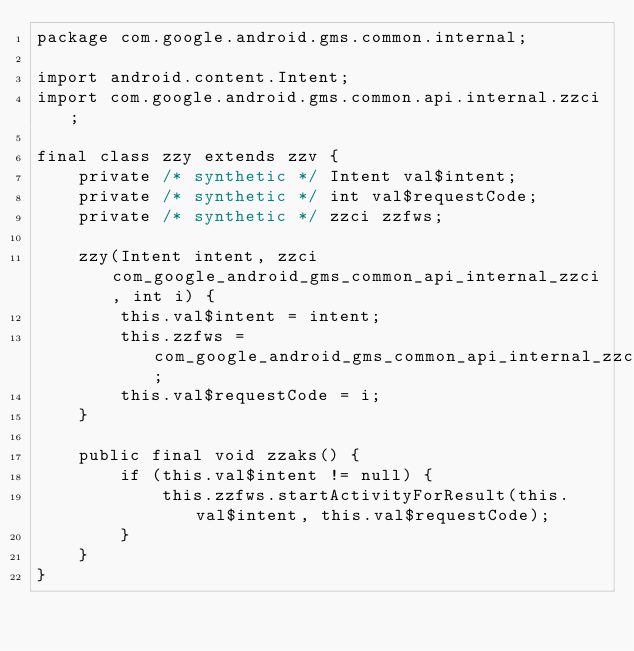<code> <loc_0><loc_0><loc_500><loc_500><_Java_>package com.google.android.gms.common.internal;

import android.content.Intent;
import com.google.android.gms.common.api.internal.zzci;

final class zzy extends zzv {
    private /* synthetic */ Intent val$intent;
    private /* synthetic */ int val$requestCode;
    private /* synthetic */ zzci zzfws;

    zzy(Intent intent, zzci com_google_android_gms_common_api_internal_zzci, int i) {
        this.val$intent = intent;
        this.zzfws = com_google_android_gms_common_api_internal_zzci;
        this.val$requestCode = i;
    }

    public final void zzaks() {
        if (this.val$intent != null) {
            this.zzfws.startActivityForResult(this.val$intent, this.val$requestCode);
        }
    }
}
</code> 